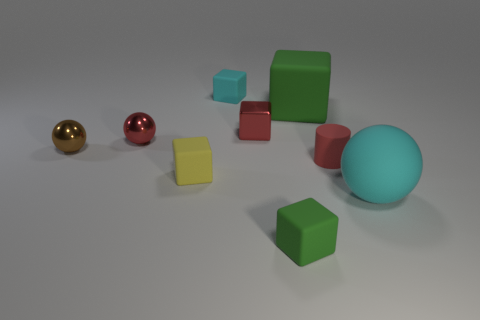Subtract all blue cubes. Subtract all brown spheres. How many cubes are left? 5 Add 1 rubber objects. How many objects exist? 10 Subtract all cylinders. How many objects are left? 8 Subtract all things. Subtract all cyan cylinders. How many objects are left? 0 Add 4 small green objects. How many small green objects are left? 5 Add 3 small metal cubes. How many small metal cubes exist? 4 Subtract 0 gray balls. How many objects are left? 9 